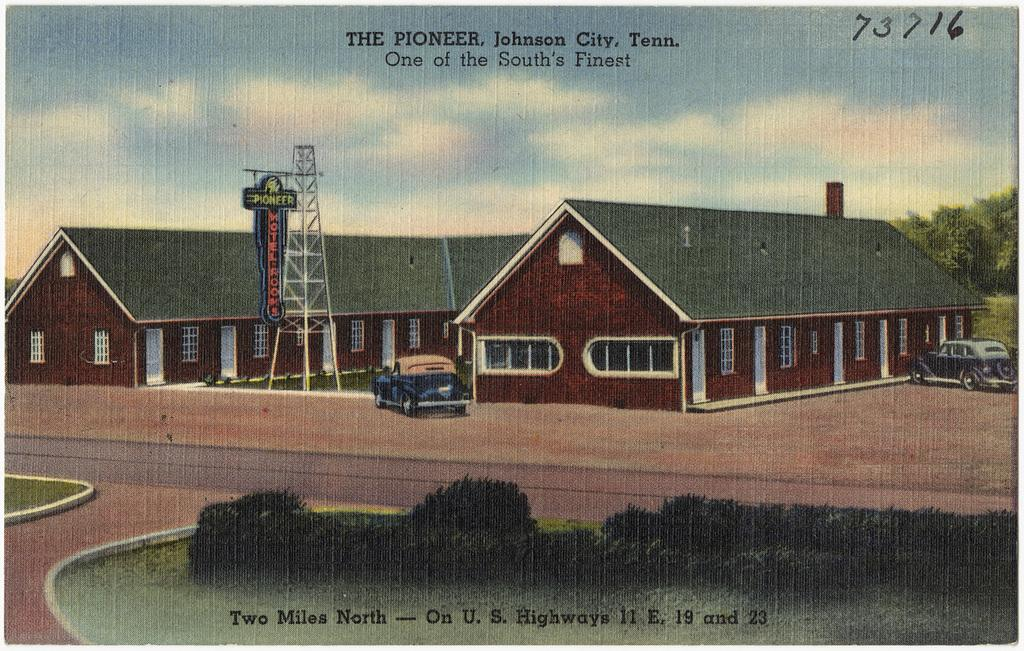What is the main subject of the painting in the image? The painting depicts houses, vehicles, plants, a tower, trees, and the sky. Can you describe the setting of the painting? The painting depicts a town or city with houses, vehicles, and a tower, surrounded by plants and trees, and with the sky visible above. Is there any text present on the image? Yes, there is something written on the image. How many edges does the painting have in the image? The painting itself does not have edges in the image, as it is a two-dimensional representation of a scene. 